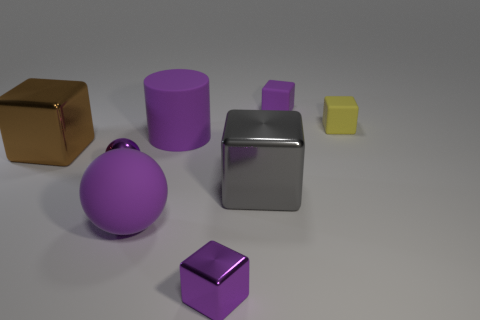Subtract 1 blocks. How many blocks are left? 4 Subtract all yellow blocks. How many blocks are left? 4 Subtract all brown metallic cubes. How many cubes are left? 4 Subtract all green blocks. Subtract all green cylinders. How many blocks are left? 5 Add 1 large purple matte cylinders. How many objects exist? 9 Subtract all cylinders. How many objects are left? 7 Add 1 gray metallic cubes. How many gray metallic cubes exist? 2 Subtract 0 cyan cubes. How many objects are left? 8 Subtract all big purple rubber things. Subtract all tiny yellow cubes. How many objects are left? 5 Add 4 rubber balls. How many rubber balls are left? 5 